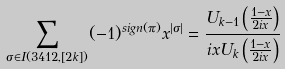Convert formula to latex. <formula><loc_0><loc_0><loc_500><loc_500>\sum _ { \sigma \in I ( 3 4 1 2 , [ 2 k ] ) } ( - 1 ) ^ { s i g n ( \pi ) } x ^ { | \sigma | } = \frac { U _ { k - 1 } \left ( \frac { 1 - x } { 2 i x } \right ) } { i x U _ { k } \left ( \frac { 1 - x } { 2 i x } \right ) }</formula> 